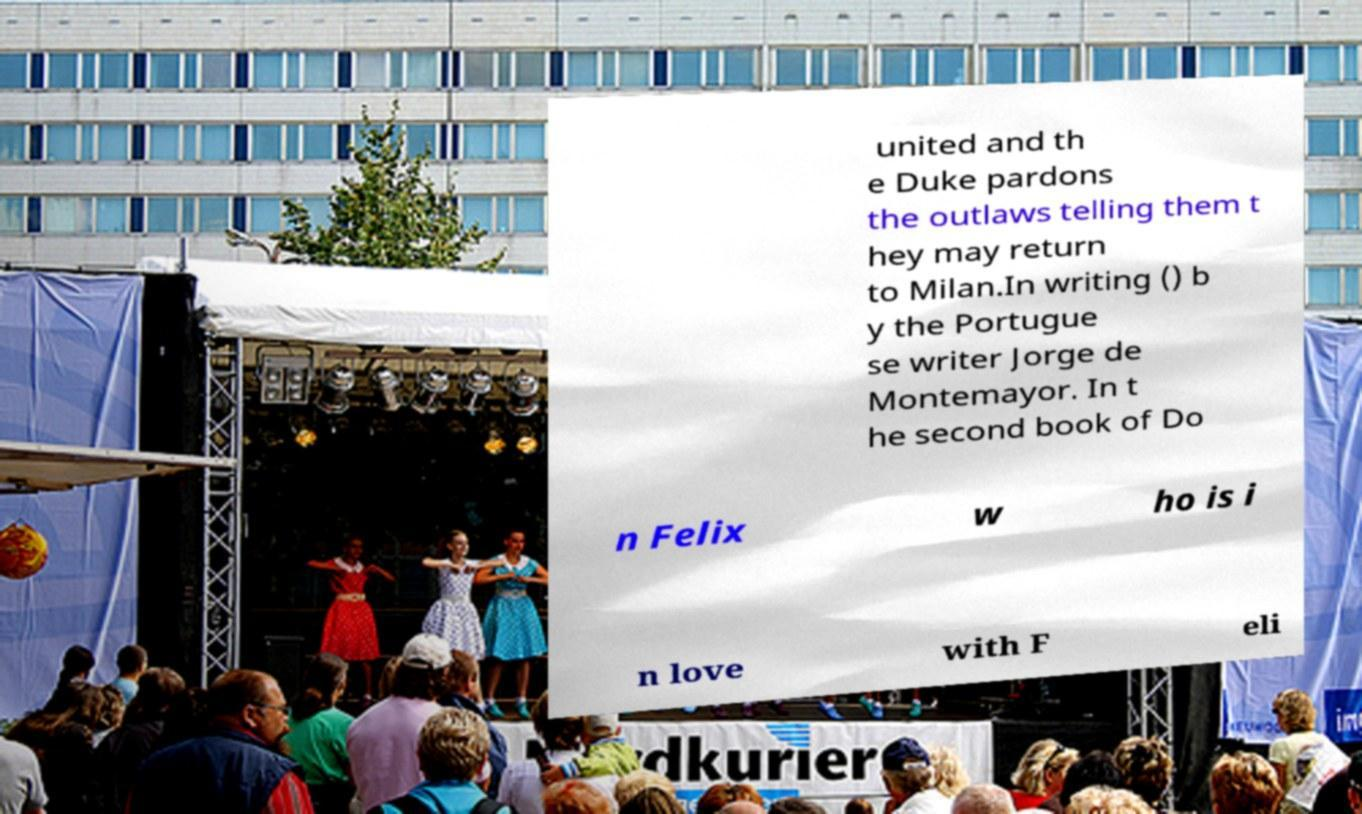For documentation purposes, I need the text within this image transcribed. Could you provide that? united and th e Duke pardons the outlaws telling them t hey may return to Milan.In writing () b y the Portugue se writer Jorge de Montemayor. In t he second book of Do n Felix w ho is i n love with F eli 